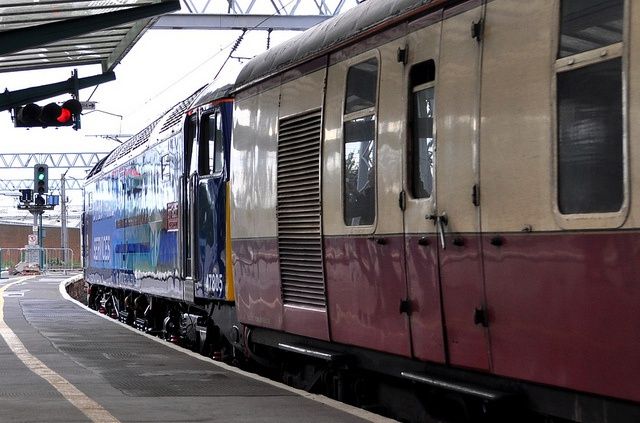Describe the objects in this image and their specific colors. I can see train in lightgray, black, gray, and maroon tones, traffic light in lightgray, black, white, red, and navy tones, and traffic light in lightgray, gray, black, and teal tones in this image. 